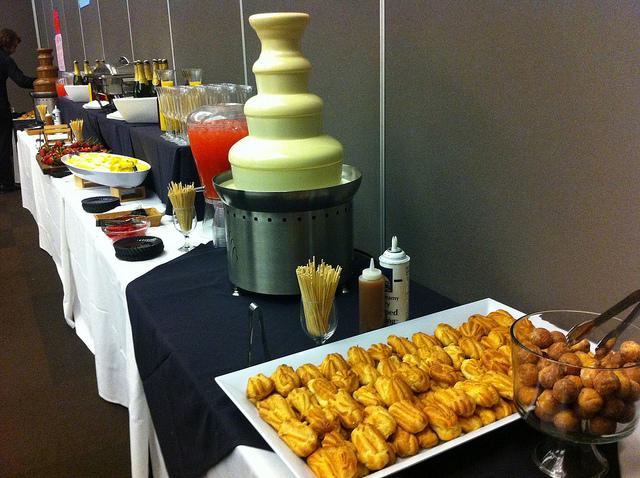What are the tongs made of?
Concise answer only. Metal. How many types of fondue are available?
Concise answer only. 1. What type of bar is this?
Quick response, please. Buffet. 